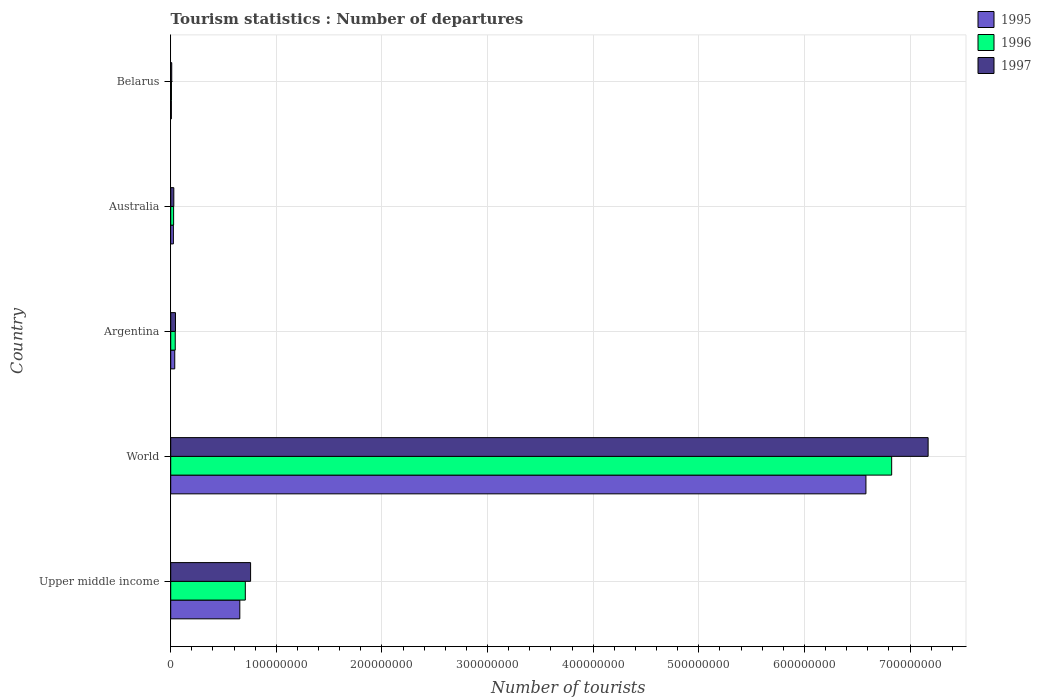How many groups of bars are there?
Offer a very short reply. 5. Are the number of bars on each tick of the Y-axis equal?
Keep it short and to the point. Yes. How many bars are there on the 2nd tick from the top?
Your answer should be very brief. 3. How many bars are there on the 5th tick from the bottom?
Make the answer very short. 3. What is the number of tourist departures in 1995 in Belarus?
Keep it short and to the point. 6.26e+05. Across all countries, what is the maximum number of tourist departures in 1995?
Your response must be concise. 6.58e+08. Across all countries, what is the minimum number of tourist departures in 1997?
Give a very brief answer. 9.69e+05. In which country was the number of tourist departures in 1996 minimum?
Offer a very short reply. Belarus. What is the total number of tourist departures in 1997 in the graph?
Give a very brief answer. 8.01e+08. What is the difference between the number of tourist departures in 1996 in Belarus and that in Upper middle income?
Give a very brief answer. -6.99e+07. What is the difference between the number of tourist departures in 1997 in Belarus and the number of tourist departures in 1996 in Australia?
Provide a succinct answer. -1.76e+06. What is the average number of tourist departures in 1996 per country?
Your answer should be very brief. 1.52e+08. What is the difference between the number of tourist departures in 1996 and number of tourist departures in 1997 in World?
Your answer should be compact. -3.45e+07. What is the ratio of the number of tourist departures in 1995 in Australia to that in Upper middle income?
Keep it short and to the point. 0.04. Is the number of tourist departures in 1995 in Australia less than that in Belarus?
Your answer should be compact. No. Is the difference between the number of tourist departures in 1996 in Upper middle income and World greater than the difference between the number of tourist departures in 1997 in Upper middle income and World?
Offer a terse response. Yes. What is the difference between the highest and the second highest number of tourist departures in 1997?
Provide a short and direct response. 6.42e+08. What is the difference between the highest and the lowest number of tourist departures in 1996?
Give a very brief answer. 6.82e+08. Is the sum of the number of tourist departures in 1996 in Argentina and Upper middle income greater than the maximum number of tourist departures in 1997 across all countries?
Offer a very short reply. No. What does the 3rd bar from the top in Belarus represents?
Give a very brief answer. 1995. What does the 2nd bar from the bottom in Belarus represents?
Your answer should be very brief. 1996. How many bars are there?
Your answer should be very brief. 15. Are all the bars in the graph horizontal?
Provide a succinct answer. Yes. How many countries are there in the graph?
Your answer should be very brief. 5. Are the values on the major ticks of X-axis written in scientific E-notation?
Give a very brief answer. No. Where does the legend appear in the graph?
Your response must be concise. Top right. How many legend labels are there?
Offer a terse response. 3. How are the legend labels stacked?
Offer a terse response. Vertical. What is the title of the graph?
Make the answer very short. Tourism statistics : Number of departures. What is the label or title of the X-axis?
Your answer should be very brief. Number of tourists. What is the label or title of the Y-axis?
Your answer should be compact. Country. What is the Number of tourists of 1995 in Upper middle income?
Your answer should be very brief. 6.54e+07. What is the Number of tourists in 1996 in Upper middle income?
Make the answer very short. 7.06e+07. What is the Number of tourists in 1997 in Upper middle income?
Give a very brief answer. 7.56e+07. What is the Number of tourists of 1995 in World?
Provide a short and direct response. 6.58e+08. What is the Number of tourists of 1996 in World?
Your answer should be compact. 6.83e+08. What is the Number of tourists of 1997 in World?
Offer a very short reply. 7.17e+08. What is the Number of tourists of 1995 in Argentina?
Give a very brief answer. 3.82e+06. What is the Number of tourists in 1996 in Argentina?
Offer a terse response. 4.30e+06. What is the Number of tourists of 1997 in Argentina?
Make the answer very short. 4.52e+06. What is the Number of tourists of 1995 in Australia?
Your response must be concise. 2.52e+06. What is the Number of tourists of 1996 in Australia?
Provide a succinct answer. 2.73e+06. What is the Number of tourists of 1997 in Australia?
Provide a succinct answer. 2.93e+06. What is the Number of tourists of 1995 in Belarus?
Provide a succinct answer. 6.26e+05. What is the Number of tourists of 1996 in Belarus?
Your answer should be compact. 7.03e+05. What is the Number of tourists of 1997 in Belarus?
Provide a succinct answer. 9.69e+05. Across all countries, what is the maximum Number of tourists in 1995?
Provide a short and direct response. 6.58e+08. Across all countries, what is the maximum Number of tourists in 1996?
Offer a very short reply. 6.83e+08. Across all countries, what is the maximum Number of tourists in 1997?
Give a very brief answer. 7.17e+08. Across all countries, what is the minimum Number of tourists of 1995?
Your answer should be compact. 6.26e+05. Across all countries, what is the minimum Number of tourists of 1996?
Ensure brevity in your answer.  7.03e+05. Across all countries, what is the minimum Number of tourists in 1997?
Ensure brevity in your answer.  9.69e+05. What is the total Number of tourists in 1995 in the graph?
Give a very brief answer. 7.31e+08. What is the total Number of tourists of 1996 in the graph?
Offer a terse response. 7.61e+08. What is the total Number of tourists of 1997 in the graph?
Provide a short and direct response. 8.01e+08. What is the difference between the Number of tourists of 1995 in Upper middle income and that in World?
Offer a terse response. -5.93e+08. What is the difference between the Number of tourists of 1996 in Upper middle income and that in World?
Provide a short and direct response. -6.12e+08. What is the difference between the Number of tourists in 1997 in Upper middle income and that in World?
Your response must be concise. -6.42e+08. What is the difference between the Number of tourists of 1995 in Upper middle income and that in Argentina?
Your answer should be compact. 6.16e+07. What is the difference between the Number of tourists in 1996 in Upper middle income and that in Argentina?
Offer a very short reply. 6.63e+07. What is the difference between the Number of tourists of 1997 in Upper middle income and that in Argentina?
Provide a short and direct response. 7.11e+07. What is the difference between the Number of tourists of 1995 in Upper middle income and that in Australia?
Keep it short and to the point. 6.29e+07. What is the difference between the Number of tourists in 1996 in Upper middle income and that in Australia?
Make the answer very short. 6.79e+07. What is the difference between the Number of tourists in 1997 in Upper middle income and that in Australia?
Your response must be concise. 7.27e+07. What is the difference between the Number of tourists of 1995 in Upper middle income and that in Belarus?
Offer a terse response. 6.48e+07. What is the difference between the Number of tourists of 1996 in Upper middle income and that in Belarus?
Provide a succinct answer. 6.99e+07. What is the difference between the Number of tourists of 1997 in Upper middle income and that in Belarus?
Provide a short and direct response. 7.47e+07. What is the difference between the Number of tourists in 1995 in World and that in Argentina?
Make the answer very short. 6.54e+08. What is the difference between the Number of tourists of 1996 in World and that in Argentina?
Your response must be concise. 6.78e+08. What is the difference between the Number of tourists of 1997 in World and that in Argentina?
Keep it short and to the point. 7.13e+08. What is the difference between the Number of tourists in 1995 in World and that in Australia?
Give a very brief answer. 6.56e+08. What is the difference between the Number of tourists in 1996 in World and that in Australia?
Keep it short and to the point. 6.80e+08. What is the difference between the Number of tourists in 1997 in World and that in Australia?
Your response must be concise. 7.14e+08. What is the difference between the Number of tourists in 1995 in World and that in Belarus?
Provide a short and direct response. 6.58e+08. What is the difference between the Number of tourists in 1996 in World and that in Belarus?
Make the answer very short. 6.82e+08. What is the difference between the Number of tourists in 1997 in World and that in Belarus?
Give a very brief answer. 7.16e+08. What is the difference between the Number of tourists in 1995 in Argentina and that in Australia?
Make the answer very short. 1.30e+06. What is the difference between the Number of tourists in 1996 in Argentina and that in Australia?
Offer a terse response. 1.56e+06. What is the difference between the Number of tourists in 1997 in Argentina and that in Australia?
Your response must be concise. 1.58e+06. What is the difference between the Number of tourists in 1995 in Argentina and that in Belarus?
Give a very brief answer. 3.19e+06. What is the difference between the Number of tourists in 1996 in Argentina and that in Belarus?
Your response must be concise. 3.59e+06. What is the difference between the Number of tourists in 1997 in Argentina and that in Belarus?
Give a very brief answer. 3.55e+06. What is the difference between the Number of tourists of 1995 in Australia and that in Belarus?
Provide a succinct answer. 1.89e+06. What is the difference between the Number of tourists in 1996 in Australia and that in Belarus?
Give a very brief answer. 2.03e+06. What is the difference between the Number of tourists in 1997 in Australia and that in Belarus?
Your answer should be very brief. 1.96e+06. What is the difference between the Number of tourists of 1995 in Upper middle income and the Number of tourists of 1996 in World?
Offer a very short reply. -6.17e+08. What is the difference between the Number of tourists of 1995 in Upper middle income and the Number of tourists of 1997 in World?
Provide a short and direct response. -6.52e+08. What is the difference between the Number of tourists in 1996 in Upper middle income and the Number of tourists in 1997 in World?
Give a very brief answer. -6.46e+08. What is the difference between the Number of tourists of 1995 in Upper middle income and the Number of tourists of 1996 in Argentina?
Your answer should be compact. 6.11e+07. What is the difference between the Number of tourists of 1995 in Upper middle income and the Number of tourists of 1997 in Argentina?
Make the answer very short. 6.09e+07. What is the difference between the Number of tourists of 1996 in Upper middle income and the Number of tourists of 1997 in Argentina?
Give a very brief answer. 6.61e+07. What is the difference between the Number of tourists of 1995 in Upper middle income and the Number of tourists of 1996 in Australia?
Your answer should be compact. 6.27e+07. What is the difference between the Number of tourists in 1995 in Upper middle income and the Number of tourists in 1997 in Australia?
Your answer should be compact. 6.25e+07. What is the difference between the Number of tourists in 1996 in Upper middle income and the Number of tourists in 1997 in Australia?
Offer a terse response. 6.77e+07. What is the difference between the Number of tourists in 1995 in Upper middle income and the Number of tourists in 1996 in Belarus?
Offer a very short reply. 6.47e+07. What is the difference between the Number of tourists in 1995 in Upper middle income and the Number of tourists in 1997 in Belarus?
Your answer should be very brief. 6.45e+07. What is the difference between the Number of tourists of 1996 in Upper middle income and the Number of tourists of 1997 in Belarus?
Provide a short and direct response. 6.97e+07. What is the difference between the Number of tourists of 1995 in World and the Number of tourists of 1996 in Argentina?
Your response must be concise. 6.54e+08. What is the difference between the Number of tourists in 1995 in World and the Number of tourists in 1997 in Argentina?
Provide a succinct answer. 6.54e+08. What is the difference between the Number of tourists in 1996 in World and the Number of tourists in 1997 in Argentina?
Offer a very short reply. 6.78e+08. What is the difference between the Number of tourists in 1995 in World and the Number of tourists in 1996 in Australia?
Ensure brevity in your answer.  6.56e+08. What is the difference between the Number of tourists of 1995 in World and the Number of tourists of 1997 in Australia?
Your answer should be compact. 6.55e+08. What is the difference between the Number of tourists of 1996 in World and the Number of tourists of 1997 in Australia?
Your answer should be compact. 6.80e+08. What is the difference between the Number of tourists of 1995 in World and the Number of tourists of 1996 in Belarus?
Give a very brief answer. 6.58e+08. What is the difference between the Number of tourists in 1995 in World and the Number of tourists in 1997 in Belarus?
Your response must be concise. 6.57e+08. What is the difference between the Number of tourists in 1996 in World and the Number of tourists in 1997 in Belarus?
Keep it short and to the point. 6.82e+08. What is the difference between the Number of tourists of 1995 in Argentina and the Number of tourists of 1996 in Australia?
Make the answer very short. 1.08e+06. What is the difference between the Number of tourists in 1995 in Argentina and the Number of tourists in 1997 in Australia?
Provide a short and direct response. 8.82e+05. What is the difference between the Number of tourists in 1996 in Argentina and the Number of tourists in 1997 in Australia?
Provide a short and direct response. 1.36e+06. What is the difference between the Number of tourists of 1995 in Argentina and the Number of tourists of 1996 in Belarus?
Offer a terse response. 3.11e+06. What is the difference between the Number of tourists in 1995 in Argentina and the Number of tourists in 1997 in Belarus?
Make the answer very short. 2.85e+06. What is the difference between the Number of tourists of 1996 in Argentina and the Number of tourists of 1997 in Belarus?
Make the answer very short. 3.33e+06. What is the difference between the Number of tourists in 1995 in Australia and the Number of tourists in 1996 in Belarus?
Make the answer very short. 1.82e+06. What is the difference between the Number of tourists of 1995 in Australia and the Number of tourists of 1997 in Belarus?
Give a very brief answer. 1.55e+06. What is the difference between the Number of tourists in 1996 in Australia and the Number of tourists in 1997 in Belarus?
Make the answer very short. 1.76e+06. What is the average Number of tourists in 1995 per country?
Give a very brief answer. 1.46e+08. What is the average Number of tourists of 1996 per country?
Ensure brevity in your answer.  1.52e+08. What is the average Number of tourists in 1997 per country?
Make the answer very short. 1.60e+08. What is the difference between the Number of tourists of 1995 and Number of tourists of 1996 in Upper middle income?
Keep it short and to the point. -5.21e+06. What is the difference between the Number of tourists in 1995 and Number of tourists in 1997 in Upper middle income?
Your answer should be very brief. -1.02e+07. What is the difference between the Number of tourists of 1996 and Number of tourists of 1997 in Upper middle income?
Your answer should be very brief. -4.99e+06. What is the difference between the Number of tourists of 1995 and Number of tourists of 1996 in World?
Offer a terse response. -2.44e+07. What is the difference between the Number of tourists in 1995 and Number of tourists in 1997 in World?
Provide a succinct answer. -5.89e+07. What is the difference between the Number of tourists in 1996 and Number of tourists in 1997 in World?
Provide a short and direct response. -3.45e+07. What is the difference between the Number of tourists of 1995 and Number of tourists of 1996 in Argentina?
Offer a very short reply. -4.81e+05. What is the difference between the Number of tourists of 1995 and Number of tourists of 1997 in Argentina?
Your answer should be very brief. -7.02e+05. What is the difference between the Number of tourists in 1996 and Number of tourists in 1997 in Argentina?
Offer a very short reply. -2.21e+05. What is the difference between the Number of tourists in 1995 and Number of tourists in 1996 in Australia?
Make the answer very short. -2.13e+05. What is the difference between the Number of tourists in 1995 and Number of tourists in 1997 in Australia?
Your response must be concise. -4.14e+05. What is the difference between the Number of tourists in 1996 and Number of tourists in 1997 in Australia?
Provide a short and direct response. -2.01e+05. What is the difference between the Number of tourists of 1995 and Number of tourists of 1996 in Belarus?
Keep it short and to the point. -7.70e+04. What is the difference between the Number of tourists in 1995 and Number of tourists in 1997 in Belarus?
Offer a terse response. -3.43e+05. What is the difference between the Number of tourists of 1996 and Number of tourists of 1997 in Belarus?
Provide a short and direct response. -2.66e+05. What is the ratio of the Number of tourists of 1995 in Upper middle income to that in World?
Offer a terse response. 0.1. What is the ratio of the Number of tourists in 1996 in Upper middle income to that in World?
Your answer should be compact. 0.1. What is the ratio of the Number of tourists of 1997 in Upper middle income to that in World?
Your answer should be very brief. 0.11. What is the ratio of the Number of tourists of 1995 in Upper middle income to that in Argentina?
Give a very brief answer. 17.15. What is the ratio of the Number of tourists of 1996 in Upper middle income to that in Argentina?
Provide a short and direct response. 16.44. What is the ratio of the Number of tourists in 1997 in Upper middle income to that in Argentina?
Provide a short and direct response. 16.74. What is the ratio of the Number of tourists in 1995 in Upper middle income to that in Australia?
Your answer should be compact. 25.97. What is the ratio of the Number of tourists of 1996 in Upper middle income to that in Australia?
Your answer should be compact. 25.85. What is the ratio of the Number of tourists in 1997 in Upper middle income to that in Australia?
Your answer should be compact. 25.78. What is the ratio of the Number of tourists in 1995 in Upper middle income to that in Belarus?
Offer a very short reply. 104.52. What is the ratio of the Number of tourists of 1996 in Upper middle income to that in Belarus?
Your answer should be compact. 100.48. What is the ratio of the Number of tourists of 1997 in Upper middle income to that in Belarus?
Keep it short and to the point. 78.04. What is the ratio of the Number of tourists in 1995 in World to that in Argentina?
Give a very brief answer. 172.54. What is the ratio of the Number of tourists in 1996 in World to that in Argentina?
Provide a short and direct response. 158.9. What is the ratio of the Number of tourists in 1997 in World to that in Argentina?
Your answer should be compact. 158.76. What is the ratio of the Number of tourists in 1995 in World to that in Australia?
Provide a succinct answer. 261.32. What is the ratio of the Number of tourists in 1996 in World to that in Australia?
Give a very brief answer. 249.86. What is the ratio of the Number of tourists in 1997 in World to that in Australia?
Your response must be concise. 244.5. What is the ratio of the Number of tourists of 1995 in World to that in Belarus?
Ensure brevity in your answer.  1051.52. What is the ratio of the Number of tourists in 1996 in World to that in Belarus?
Make the answer very short. 971.02. What is the ratio of the Number of tourists of 1997 in World to that in Belarus?
Keep it short and to the point. 740.08. What is the ratio of the Number of tourists of 1995 in Argentina to that in Australia?
Your answer should be very brief. 1.51. What is the ratio of the Number of tourists of 1996 in Argentina to that in Australia?
Offer a very short reply. 1.57. What is the ratio of the Number of tourists of 1997 in Argentina to that in Australia?
Offer a terse response. 1.54. What is the ratio of the Number of tourists of 1995 in Argentina to that in Belarus?
Keep it short and to the point. 6.09. What is the ratio of the Number of tourists in 1996 in Argentina to that in Belarus?
Keep it short and to the point. 6.11. What is the ratio of the Number of tourists in 1997 in Argentina to that in Belarus?
Your answer should be compact. 4.66. What is the ratio of the Number of tourists in 1995 in Australia to that in Belarus?
Ensure brevity in your answer.  4.02. What is the ratio of the Number of tourists of 1996 in Australia to that in Belarus?
Provide a succinct answer. 3.89. What is the ratio of the Number of tourists in 1997 in Australia to that in Belarus?
Give a very brief answer. 3.03. What is the difference between the highest and the second highest Number of tourists of 1995?
Offer a very short reply. 5.93e+08. What is the difference between the highest and the second highest Number of tourists of 1996?
Give a very brief answer. 6.12e+08. What is the difference between the highest and the second highest Number of tourists in 1997?
Provide a succinct answer. 6.42e+08. What is the difference between the highest and the lowest Number of tourists of 1995?
Your answer should be compact. 6.58e+08. What is the difference between the highest and the lowest Number of tourists in 1996?
Your answer should be compact. 6.82e+08. What is the difference between the highest and the lowest Number of tourists in 1997?
Your answer should be very brief. 7.16e+08. 